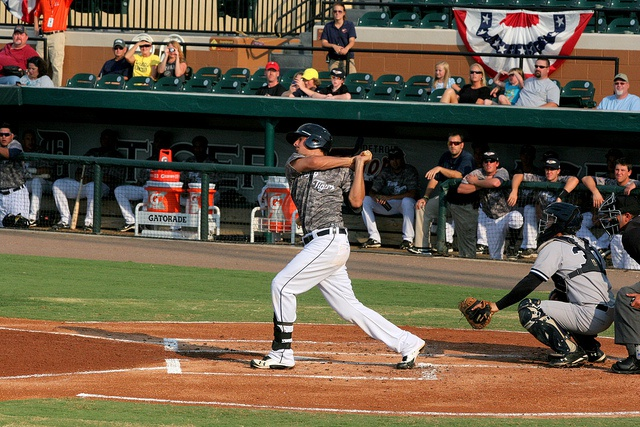Describe the objects in this image and their specific colors. I can see people in gray, lightgray, black, and darkgray tones, people in gray, black, darkgray, and lightgray tones, people in gray, black, salmon, and brown tones, people in gray, black, brown, and tan tones, and people in gray, black, and brown tones in this image. 